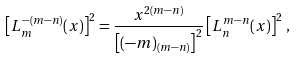Convert formula to latex. <formula><loc_0><loc_0><loc_500><loc_500>\left [ L _ { m } ^ { - ( m - n ) } ( x ) \right ] ^ { 2 } = \frac { x ^ { 2 ( m - n ) } } { \left [ ( - m ) _ { ( m - n ) } \right ] ^ { 2 } } \left [ L _ { n } ^ { m - n } ( x ) \right ] ^ { 2 } \, ,</formula> 